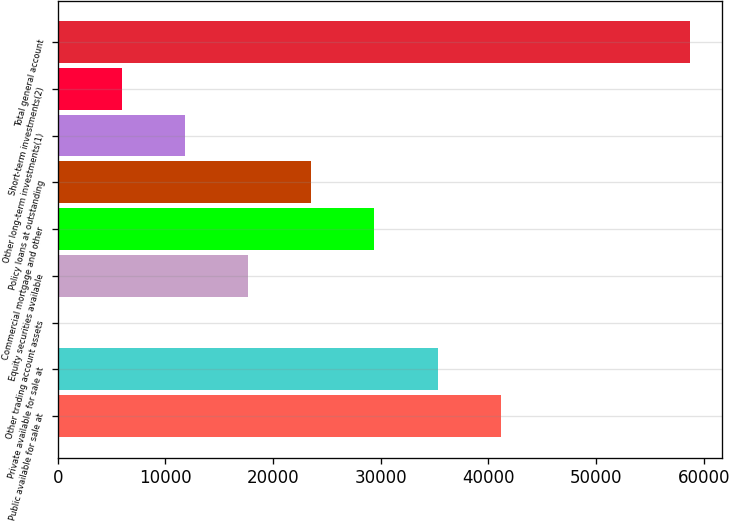Convert chart. <chart><loc_0><loc_0><loc_500><loc_500><bar_chart><fcel>Public available for sale at<fcel>Private available for sale at<fcel>Other trading account assets<fcel>Equity securities available<fcel>Commercial mortgage and other<fcel>Policy loans at outstanding<fcel>Other long-term investments(1)<fcel>Short-term investments(2)<fcel>Total general account<nl><fcel>41130.9<fcel>35272.2<fcel>120<fcel>17696.1<fcel>29413.5<fcel>23554.8<fcel>11837.4<fcel>5978.7<fcel>58707<nl></chart> 